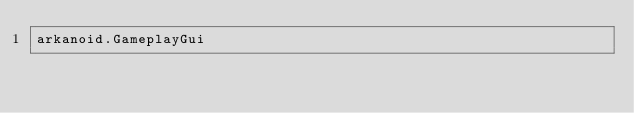Convert code to text. <code><loc_0><loc_0><loc_500><loc_500><_Rust_>arkanoid.GameplayGui
</code> 